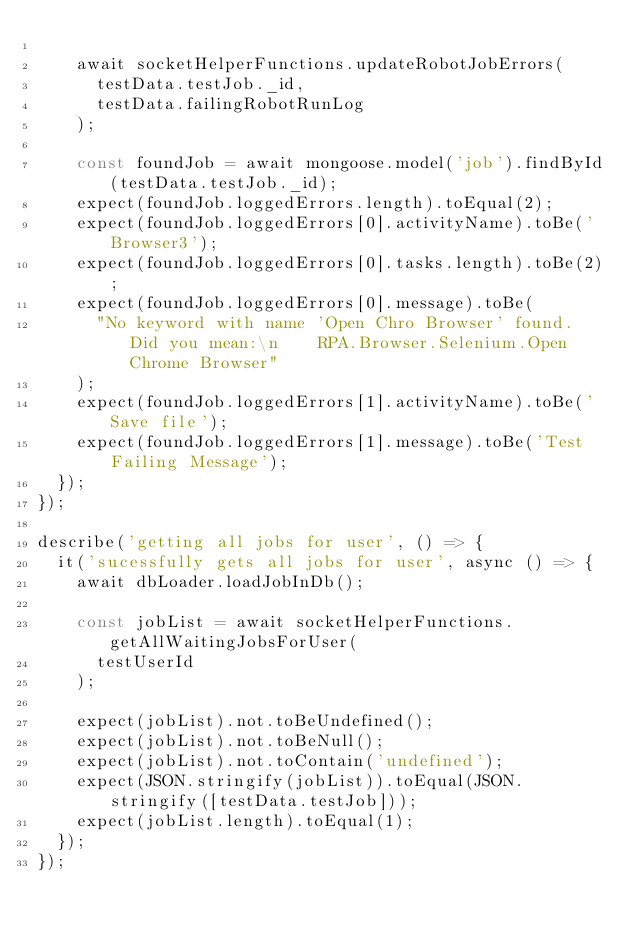Convert code to text. <code><loc_0><loc_0><loc_500><loc_500><_JavaScript_>
    await socketHelperFunctions.updateRobotJobErrors(
      testData.testJob._id,
      testData.failingRobotRunLog
    );

    const foundJob = await mongoose.model('job').findById(testData.testJob._id);
    expect(foundJob.loggedErrors.length).toEqual(2);
    expect(foundJob.loggedErrors[0].activityName).toBe('Browser3');
    expect(foundJob.loggedErrors[0].tasks.length).toBe(2);
    expect(foundJob.loggedErrors[0].message).toBe(
      "No keyword with name 'Open Chro Browser' found. Did you mean:\n    RPA.Browser.Selenium.Open Chrome Browser"
    );
    expect(foundJob.loggedErrors[1].activityName).toBe('Save file');
    expect(foundJob.loggedErrors[1].message).toBe('Test Failing Message');
  });
});

describe('getting all jobs for user', () => {
  it('sucessfully gets all jobs for user', async () => {
    await dbLoader.loadJobInDb();

    const jobList = await socketHelperFunctions.getAllWaitingJobsForUser(
      testUserId
    );

    expect(jobList).not.toBeUndefined();
    expect(jobList).not.toBeNull();
    expect(jobList).not.toContain('undefined');
    expect(JSON.stringify(jobList)).toEqual(JSON.stringify([testData.testJob]));
    expect(jobList.length).toEqual(1);
  });
});
</code> 